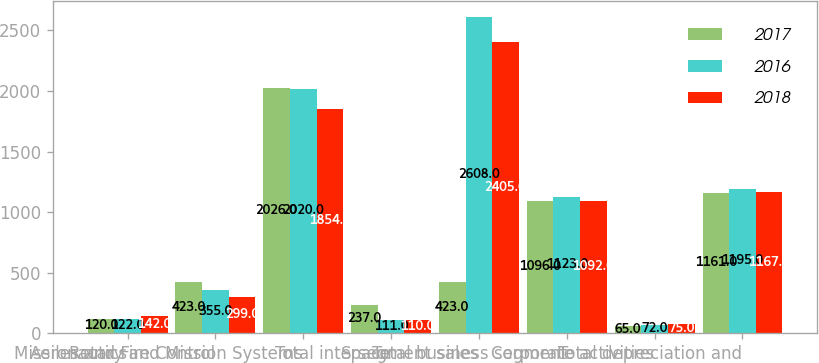Convert chart. <chart><loc_0><loc_0><loc_500><loc_500><stacked_bar_chart><ecel><fcel>Aeronautics<fcel>Missiles and Fire Control<fcel>Rotary and Mission Systems<fcel>Space<fcel>Total intersegment sales<fcel>Total business segment<fcel>Corporate activities<fcel>Total depreciation and<nl><fcel>2017<fcel>120<fcel>423<fcel>2026<fcel>237<fcel>423<fcel>1096<fcel>65<fcel>1161<nl><fcel>2016<fcel>122<fcel>355<fcel>2020<fcel>111<fcel>2608<fcel>1123<fcel>72<fcel>1195<nl><fcel>2018<fcel>142<fcel>299<fcel>1854<fcel>110<fcel>2405<fcel>1092<fcel>75<fcel>1167<nl></chart> 